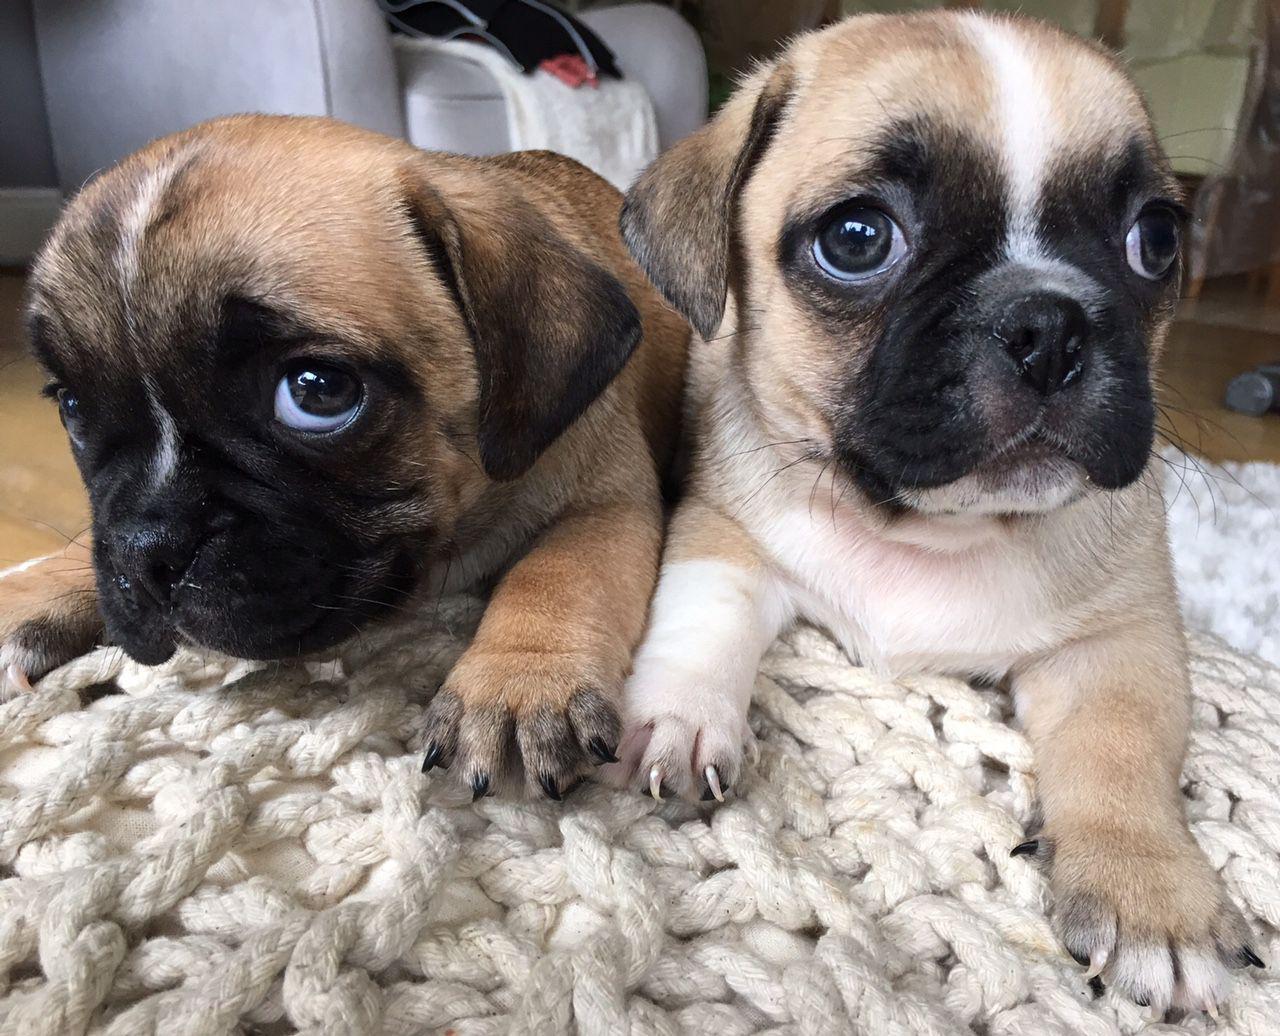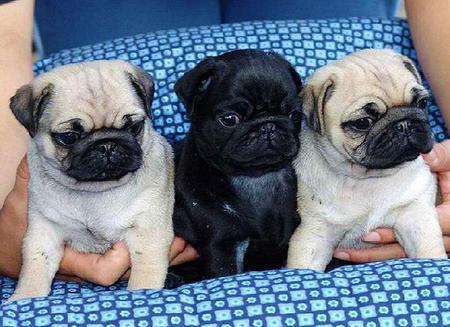The first image is the image on the left, the second image is the image on the right. Given the left and right images, does the statement "Each image contains multiple pugs, and one image shows a trio of pugs with a black one in the middle." hold true? Answer yes or no. Yes. The first image is the image on the left, the second image is the image on the right. Given the left and right images, does the statement "There are exactly three dogs in the right image." hold true? Answer yes or no. Yes. 